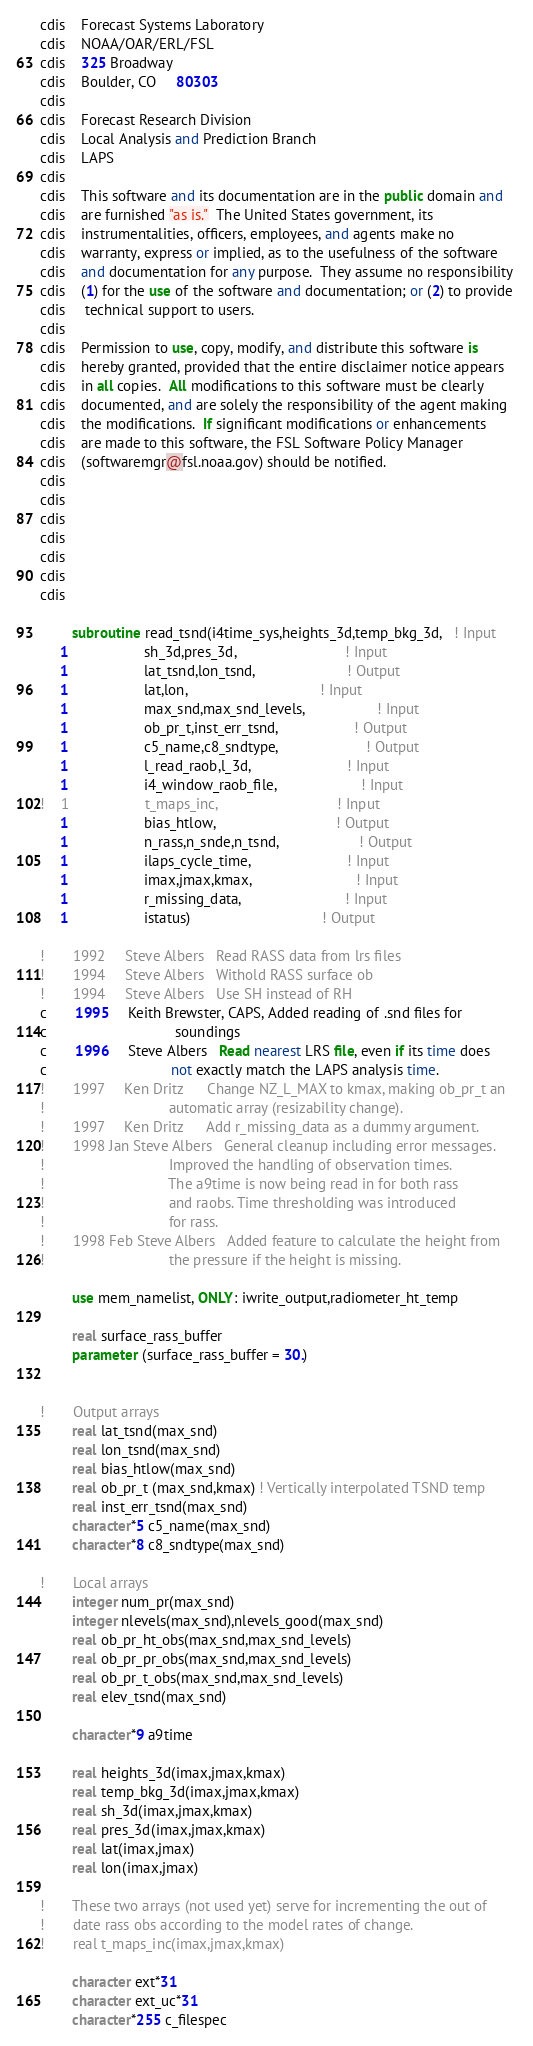Convert code to text. <code><loc_0><loc_0><loc_500><loc_500><_FORTRAN_>cdis    Forecast Systems Laboratory
cdis    NOAA/OAR/ERL/FSL
cdis    325 Broadway
cdis    Boulder, CO     80303
cdis 
cdis    Forecast Research Division
cdis    Local Analysis and Prediction Branch
cdis    LAPS 
cdis 
cdis    This software and its documentation are in the public domain and 
cdis    are furnished "as is."  The United States government, its 
cdis    instrumentalities, officers, employees, and agents make no 
cdis    warranty, express or implied, as to the usefulness of the software 
cdis    and documentation for any purpose.  They assume no responsibility 
cdis    (1) for the use of the software and documentation; or (2) to provide
cdis     technical support to users.
cdis    
cdis    Permission to use, copy, modify, and distribute this software is
cdis    hereby granted, provided that the entire disclaimer notice appears
cdis    in all copies.  All modifications to this software must be clearly
cdis    documented, and are solely the responsibility of the agent making 
cdis    the modifications.  If significant modifications or enhancements 
cdis    are made to this software, the FSL Software Policy Manager  
cdis    (softwaremgr@fsl.noaa.gov) should be notified.
cdis 
cdis 
cdis 
cdis 
cdis 
cdis 
cdis 

        subroutine read_tsnd(i4time_sys,heights_3d,temp_bkg_3d,   ! Input
     1                   sh_3d,pres_3d,                           ! Input
     1                   lat_tsnd,lon_tsnd,                       ! Output
     1                   lat,lon,                                 ! Input
     1                   max_snd,max_snd_levels,                  ! Input
     1                   ob_pr_t,inst_err_tsnd,                   ! Output
     1                   c5_name,c8_sndtype,                      ! Output
     1                   l_read_raob,l_3d,                        ! Input
     1                   i4_window_raob_file,                     ! Input
!    1                   t_maps_inc,                              ! Input
     1                   bias_htlow,                              ! Output
     1                   n_rass,n_snde,n_tsnd,                    ! Output
     1                   ilaps_cycle_time,                        ! Input
     1                   imax,jmax,kmax,                          ! Input
     1                   r_missing_data,                          ! Input
     1                   istatus)                                 ! Output

!       1992     Steve Albers   Read RASS data from lrs files
!       1994     Steve Albers   Withold RASS surface ob
!       1994     Steve Albers   Use SH instead of RH
c       1995     Keith Brewster, CAPS, Added reading of .snd files for
c                                soundings
c       1996     Steve Albers   Read nearest LRS file, even if its time does
c                               not exactly match the LAPS analysis time. 
!       1997     Ken Dritz      Change NZ_L_MAX to kmax, making ob_pr_t an
!                               automatic array (resizability change).
!       1997     Ken Dritz      Add r_missing_data as a dummy argument.
!       1998 Jan Steve Albers   General cleanup including error messages.
!                               Improved the handling of observation times. 
!                               The a9time is now being read in for both rass
!                               and raobs. Time thresholding was introduced 
!                               for rass.
!       1998 Feb Steve Albers   Added feature to calculate the height from
!                               the pressure if the height is missing.

        use mem_namelist, ONLY: iwrite_output,radiometer_ht_temp

        real surface_rass_buffer
        parameter (surface_rass_buffer = 30.)


!       Output arrays
        real lat_tsnd(max_snd)
        real lon_tsnd(max_snd)
        real bias_htlow(max_snd)
        real ob_pr_t (max_snd,kmax) ! Vertically interpolated TSND temp
        real inst_err_tsnd(max_snd)
        character*5 c5_name(max_snd) 
        character*8 c8_sndtype(max_snd) 

!       Local arrays
        integer num_pr(max_snd)
        integer nlevels(max_snd),nlevels_good(max_snd)
        real ob_pr_ht_obs(max_snd,max_snd_levels)
        real ob_pr_pr_obs(max_snd,max_snd_levels)
        real ob_pr_t_obs(max_snd,max_snd_levels)
        real elev_tsnd(max_snd)

        character*9 a9time

        real heights_3d(imax,jmax,kmax)
        real temp_bkg_3d(imax,jmax,kmax)
        real sh_3d(imax,jmax,kmax)
        real pres_3d(imax,jmax,kmax)
        real lat(imax,jmax)
        real lon(imax,jmax)

!       These two arrays (not used yet) serve for incrementing the out of
!       date rass obs according to the model rates of change.
!       real t_maps_inc(imax,jmax,kmax)

        character ext*31
        character ext_uc*31
        character*255 c_filespec
</code> 